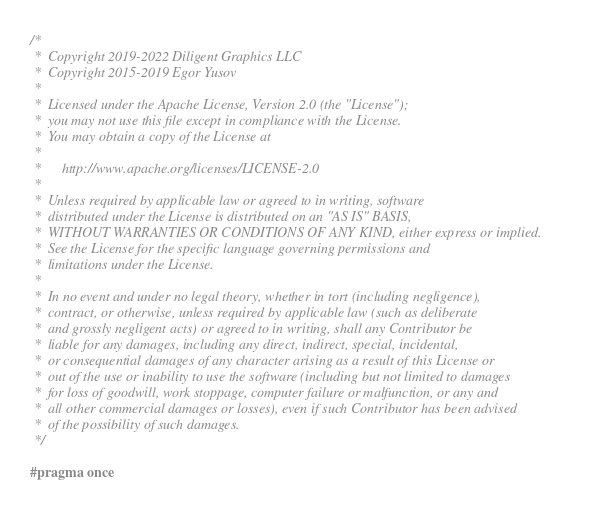Convert code to text. <code><loc_0><loc_0><loc_500><loc_500><_C++_>/*
 *  Copyright 2019-2022 Diligent Graphics LLC
 *  Copyright 2015-2019 Egor Yusov
 *
 *  Licensed under the Apache License, Version 2.0 (the "License");
 *  you may not use this file except in compliance with the License.
 *  You may obtain a copy of the License at
 *
 *      http://www.apache.org/licenses/LICENSE-2.0
 *
 *  Unless required by applicable law or agreed to in writing, software
 *  distributed under the License is distributed on an "AS IS" BASIS,
 *  WITHOUT WARRANTIES OR CONDITIONS OF ANY KIND, either express or implied.
 *  See the License for the specific language governing permissions and
 *  limitations under the License.
 *
 *  In no event and under no legal theory, whether in tort (including negligence),
 *  contract, or otherwise, unless required by applicable law (such as deliberate
 *  and grossly negligent acts) or agreed to in writing, shall any Contributor be
 *  liable for any damages, including any direct, indirect, special, incidental,
 *  or consequential damages of any character arising as a result of this License or
 *  out of the use or inability to use the software (including but not limited to damages
 *  for loss of goodwill, work stoppage, computer failure or malfunction, or any and
 *  all other commercial damages or losses), even if such Contributor has been advised
 *  of the possibility of such damages.
 */

#pragma once
</code> 